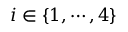Convert formula to latex. <formula><loc_0><loc_0><loc_500><loc_500>i \in \{ 1 , \cdots , 4 \}</formula> 